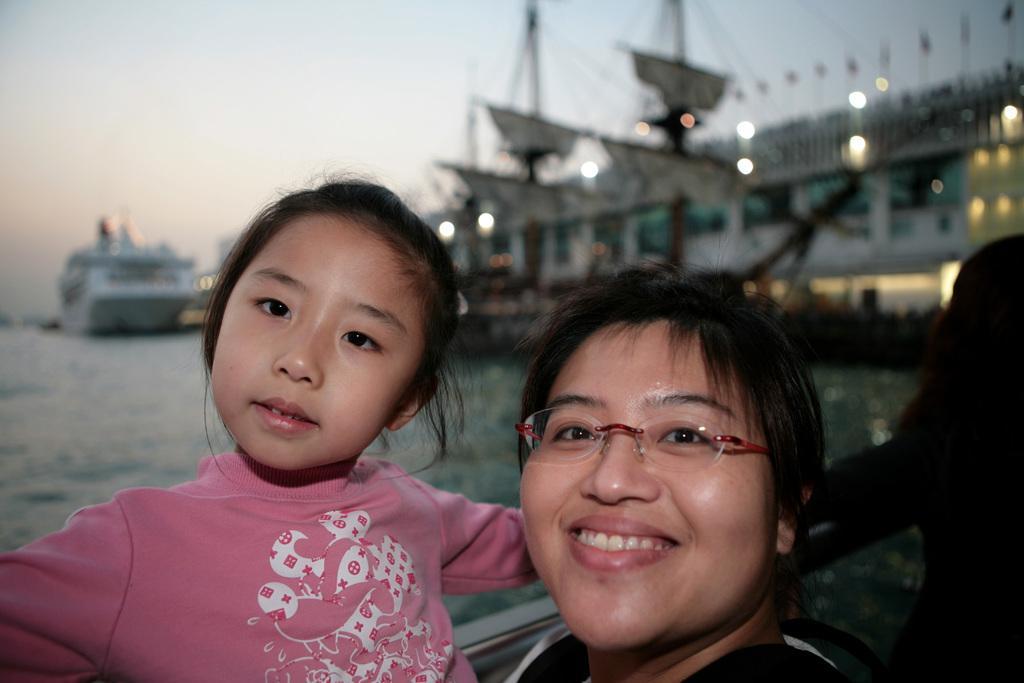Can you describe this image briefly? In the foreground I can see three persons near the fence. In the background I can see boats in the water, buildings, lights and the sky. This image is taken may be in the ocean. 